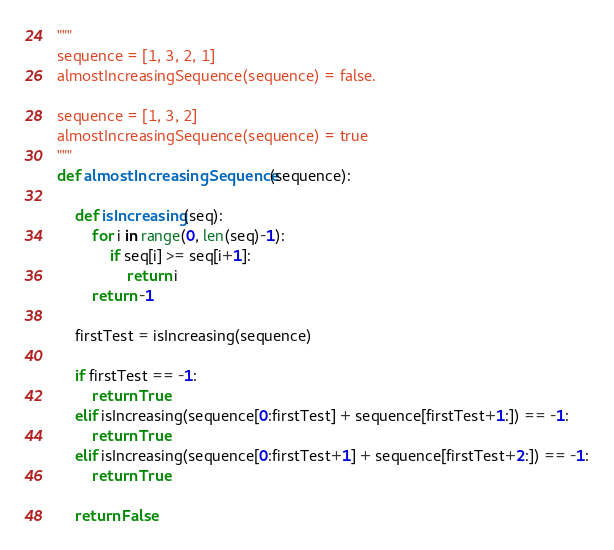<code> <loc_0><loc_0><loc_500><loc_500><_Python_>"""
sequence = [1, 3, 2, 1]
almostIncreasingSequence(sequence) = false.

sequence = [1, 3, 2]
almostIncreasingSequence(sequence) = true
"""
def almostIncreasingSequence(sequence):
    
    def isIncreasing(seq):
        for i in range(0, len(seq)-1):
            if seq[i] >= seq[i+1]:
                return i
        return -1
        
    firstTest = isIncreasing(sequence)

    if firstTest == -1:
        return True
    elif isIncreasing(sequence[0:firstTest] + sequence[firstTest+1:]) == -1:
        return True 
    elif isIncreasing(sequence[0:firstTest+1] + sequence[firstTest+2:]) == -1:
        return True 
    
    return False</code> 